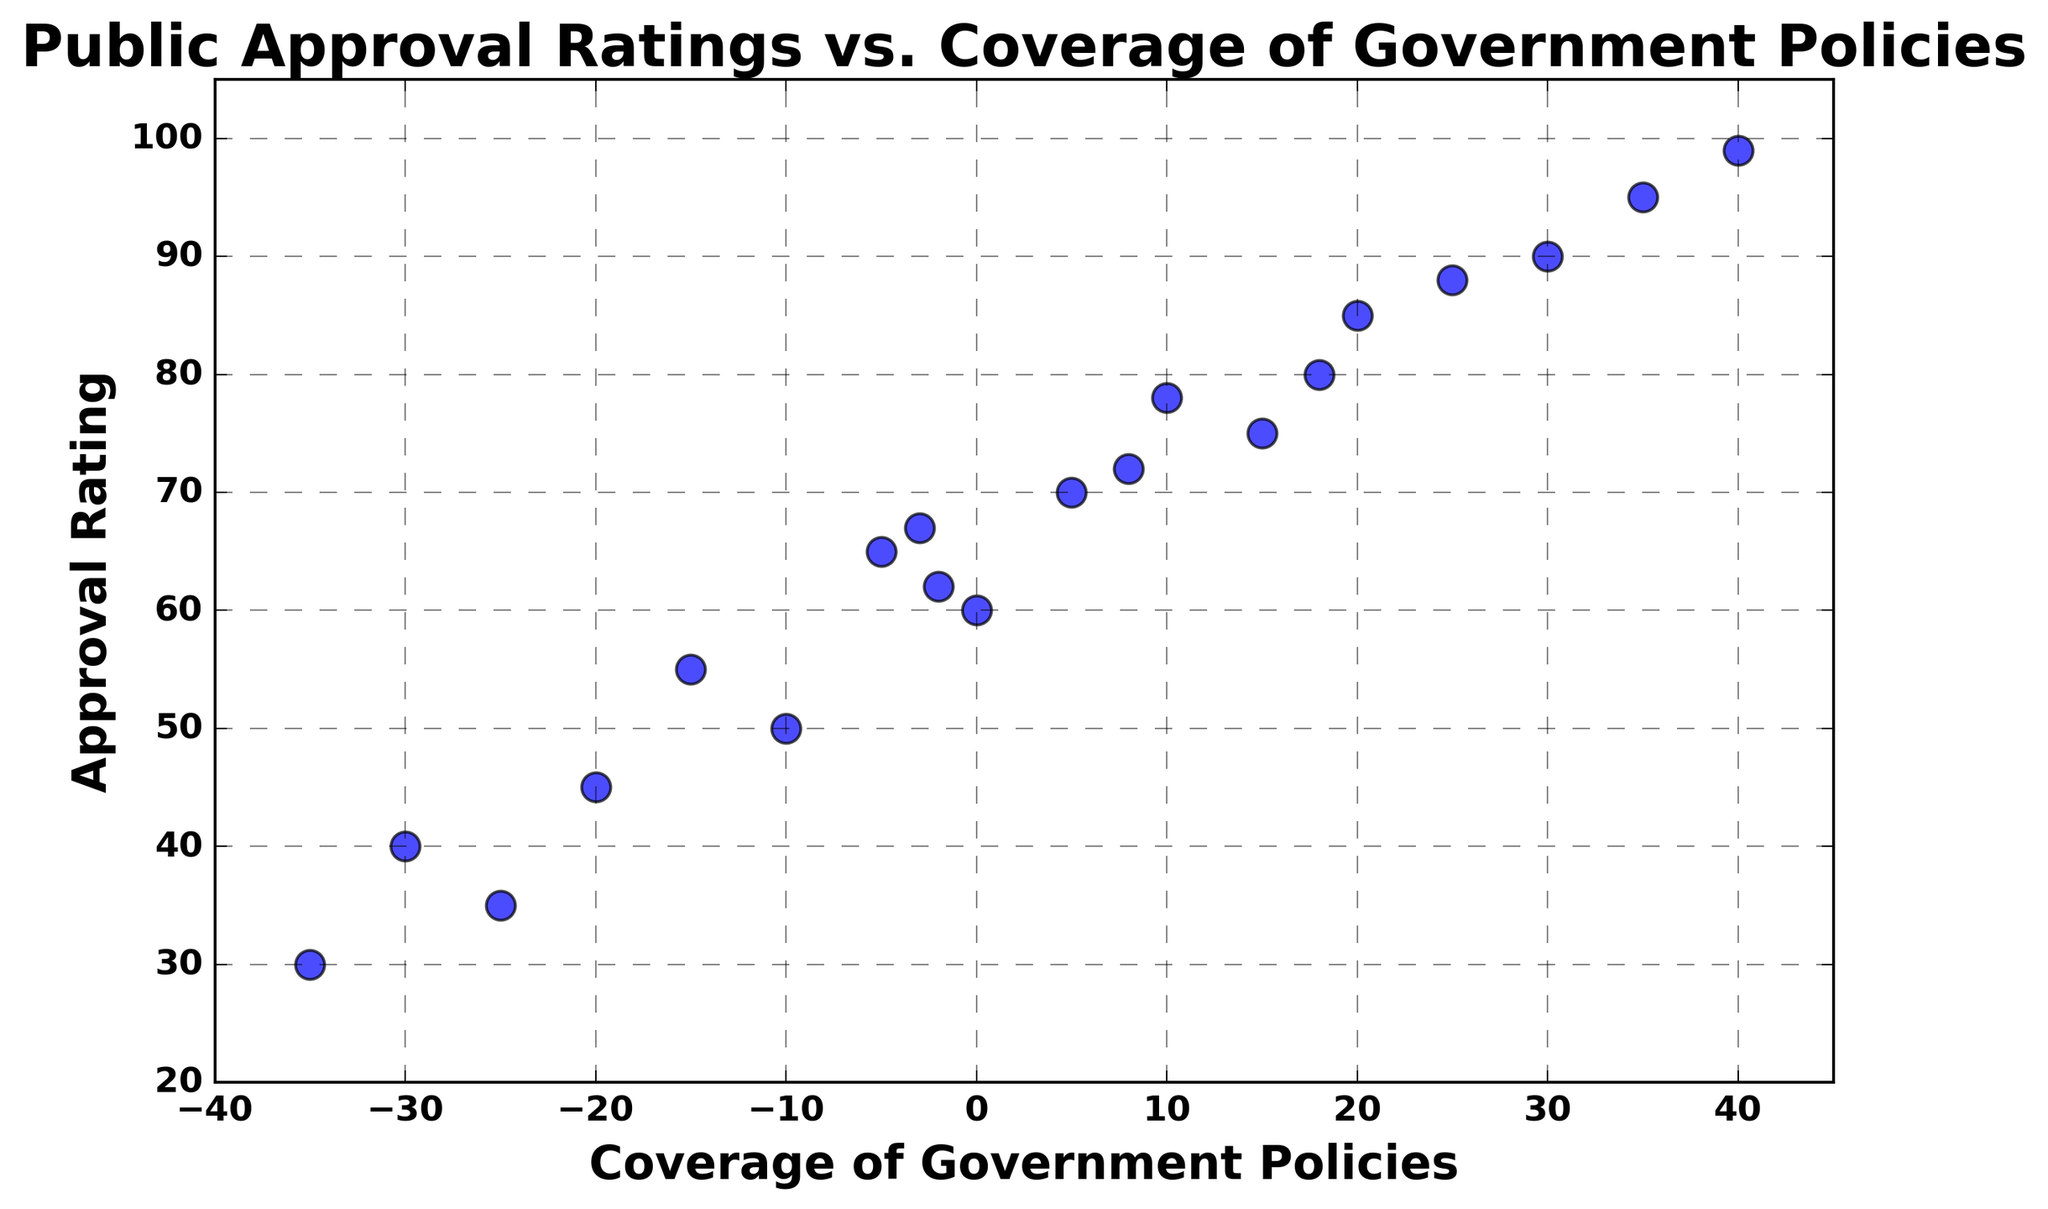What is the highest approval rating observed in the scatter plot? The highest point on the y-axis corresponds to the highest approval rating, which is 99.
Answer: 99 How many data points have a negative coverage of government policies? Count the points with their x-coordinate (coverage of government policies) less than zero. The data shows 10 such points.
Answer: 10 Which data point has the lowest approval rating and what is its coverage of government policies? Find the lowest point on the y-axis and check its corresponding x-coordinate. The lowest approval rating is 30, with a coverage of government policies of -35.
Answer: 30, -35 Is there any data point where both the approval rating and coverage of government policies are at their maximum values? The highest approval rating is 99 (y-coordinate) and the highest coverage of government policies is 40 (x-coordinate), and they occur at the same data point.
Answer: Yes What is the average approval rating for data points where the coverage of government policies is non-negative? Sum the approval ratings of points with non-negative coverage (75, 70, 90, 60, 85, 80, 95, 78, 72, and 88) and divide by the count of these points. (75+70+90+60+85+80+95+78+72+88) = 793, and there are 10 such points, so the average is 793/10 = 79.3.
Answer: 79.3 What is the difference between the highest and lowest coverage of government policies observed? Subtract the minimum coverage from the maximum coverage: 40 - (-35) = 75.
Answer: 75 Which data point shows an approval rating of 50, and what is its coverage of government policies? Find the point with the y-coordinate of 50, which corresponds to an x-coordinate of -10.
Answer: 50, -10 Is there a clear trend between the coverage of government policies and public approval ratings? Observing the scatter plot, though there might seem some clusters, overall the points appear scattered without a strong visible correlation.
Answer: No What is the median value of approval ratings? Arrange approval ratings in ascending order and find the middle value. The ordered values are 30, 35, 40, 45, 50, 55, 60, 62, 65, 67, 70, 72, 75, 78, 80, 85, 88, 90, 95, 99. The middle values are 70 and 72. Median = (70 + 72) / 2 = 71.
Answer: 71 